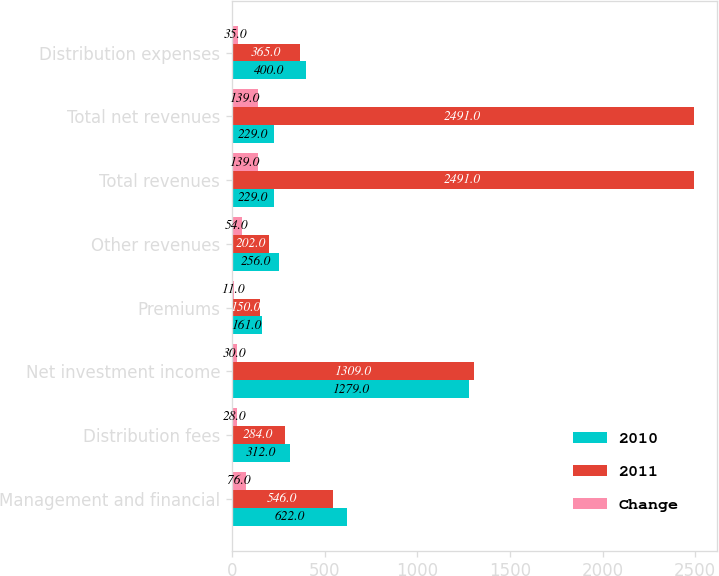Convert chart. <chart><loc_0><loc_0><loc_500><loc_500><stacked_bar_chart><ecel><fcel>Management and financial<fcel>Distribution fees<fcel>Net investment income<fcel>Premiums<fcel>Other revenues<fcel>Total revenues<fcel>Total net revenues<fcel>Distribution expenses<nl><fcel>2010<fcel>622<fcel>312<fcel>1279<fcel>161<fcel>256<fcel>229<fcel>229<fcel>400<nl><fcel>2011<fcel>546<fcel>284<fcel>1309<fcel>150<fcel>202<fcel>2491<fcel>2491<fcel>365<nl><fcel>Change<fcel>76<fcel>28<fcel>30<fcel>11<fcel>54<fcel>139<fcel>139<fcel>35<nl></chart> 